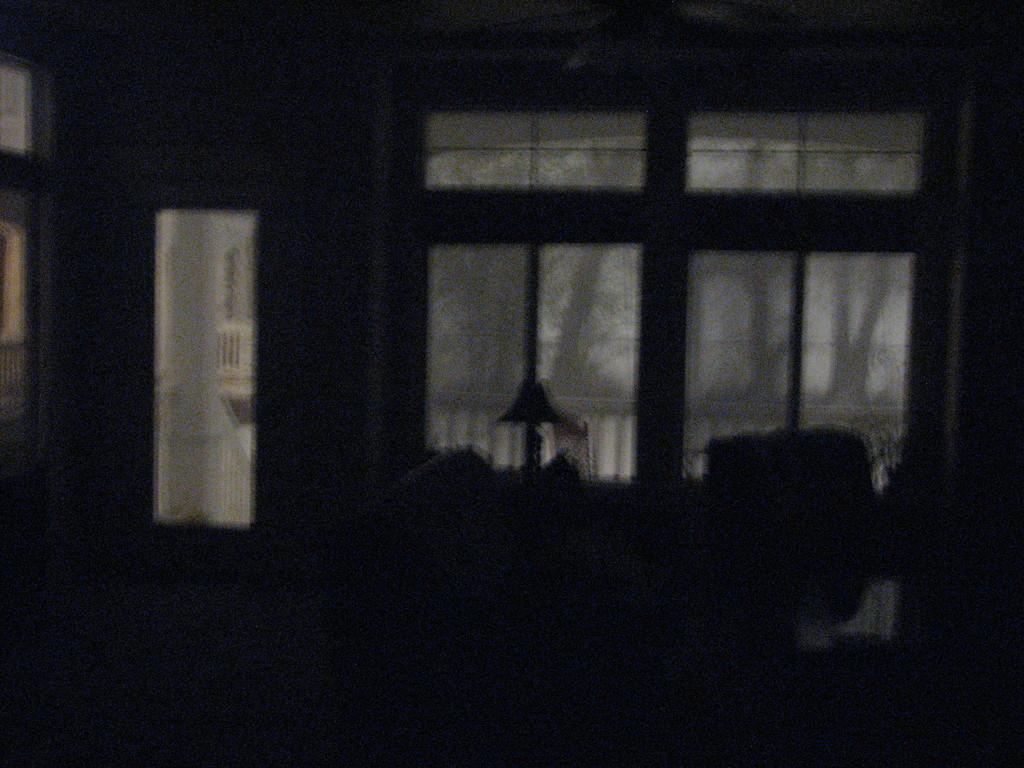Where was the image taken? The image was taken inside a house. What can be seen through the windows in the image? The image does not show what can be seen through the windows. What objects are made of glass in the image? There are glasses in the image. What is the purpose of the door in the image? The door's purpose is not specified in the image. What type of stem can be seen growing from the floor in the image? There is no stem growing from the floor in the image. 